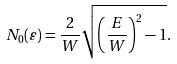Convert formula to latex. <formula><loc_0><loc_0><loc_500><loc_500>N _ { 0 } ( \varepsilon ) = \frac { 2 } { W } \sqrt { \left ( \frac { E } { W } \right ) ^ { 2 } - 1 } .</formula> 